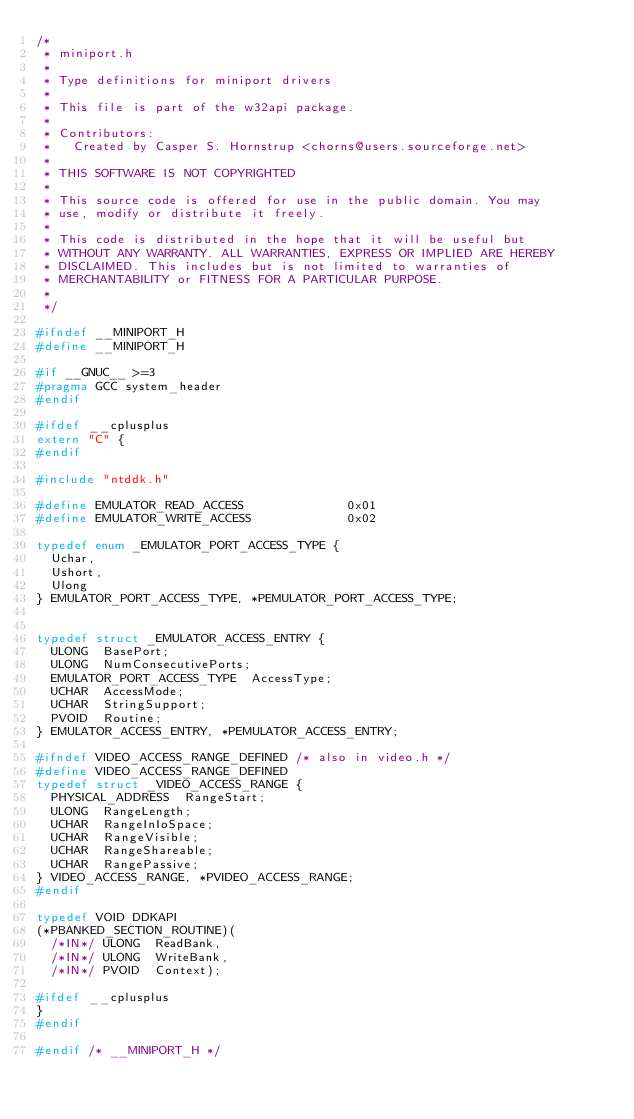<code> <loc_0><loc_0><loc_500><loc_500><_C_>/*
 * miniport.h
 *
 * Type definitions for miniport drivers
 *
 * This file is part of the w32api package.
 *
 * Contributors:
 *   Created by Casper S. Hornstrup <chorns@users.sourceforge.net>
 *
 * THIS SOFTWARE IS NOT COPYRIGHTED
 *
 * This source code is offered for use in the public domain. You may
 * use, modify or distribute it freely.
 *
 * This code is distributed in the hope that it will be useful but
 * WITHOUT ANY WARRANTY. ALL WARRANTIES, EXPRESS OR IMPLIED ARE HEREBY
 * DISCLAIMED. This includes but is not limited to warranties of
 * MERCHANTABILITY or FITNESS FOR A PARTICULAR PURPOSE.
 *
 */

#ifndef __MINIPORT_H
#define __MINIPORT_H

#if __GNUC__ >=3
#pragma GCC system_header
#endif

#ifdef __cplusplus
extern "C" {
#endif

#include "ntddk.h"

#define EMULATOR_READ_ACCESS              0x01
#define EMULATOR_WRITE_ACCESS             0x02

typedef enum _EMULATOR_PORT_ACCESS_TYPE {
	Uchar,
	Ushort,
	Ulong
} EMULATOR_PORT_ACCESS_TYPE, *PEMULATOR_PORT_ACCESS_TYPE;


typedef struct _EMULATOR_ACCESS_ENTRY {
  ULONG  BasePort;
  ULONG  NumConsecutivePorts;
  EMULATOR_PORT_ACCESS_TYPE  AccessType;
  UCHAR  AccessMode;
  UCHAR  StringSupport;
  PVOID  Routine;
} EMULATOR_ACCESS_ENTRY, *PEMULATOR_ACCESS_ENTRY;

#ifndef VIDEO_ACCESS_RANGE_DEFINED /* also in video.h */
#define VIDEO_ACCESS_RANGE_DEFINED
typedef struct _VIDEO_ACCESS_RANGE {
  PHYSICAL_ADDRESS  RangeStart;
  ULONG  RangeLength;
  UCHAR  RangeInIoSpace;
  UCHAR  RangeVisible;
  UCHAR  RangeShareable;
  UCHAR  RangePassive;
} VIDEO_ACCESS_RANGE, *PVIDEO_ACCESS_RANGE;
#endif

typedef VOID DDKAPI
(*PBANKED_SECTION_ROUTINE)(
  /*IN*/ ULONG  ReadBank,
  /*IN*/ ULONG  WriteBank,
  /*IN*/ PVOID  Context);

#ifdef __cplusplus
}
#endif

#endif /* __MINIPORT_H */
</code> 